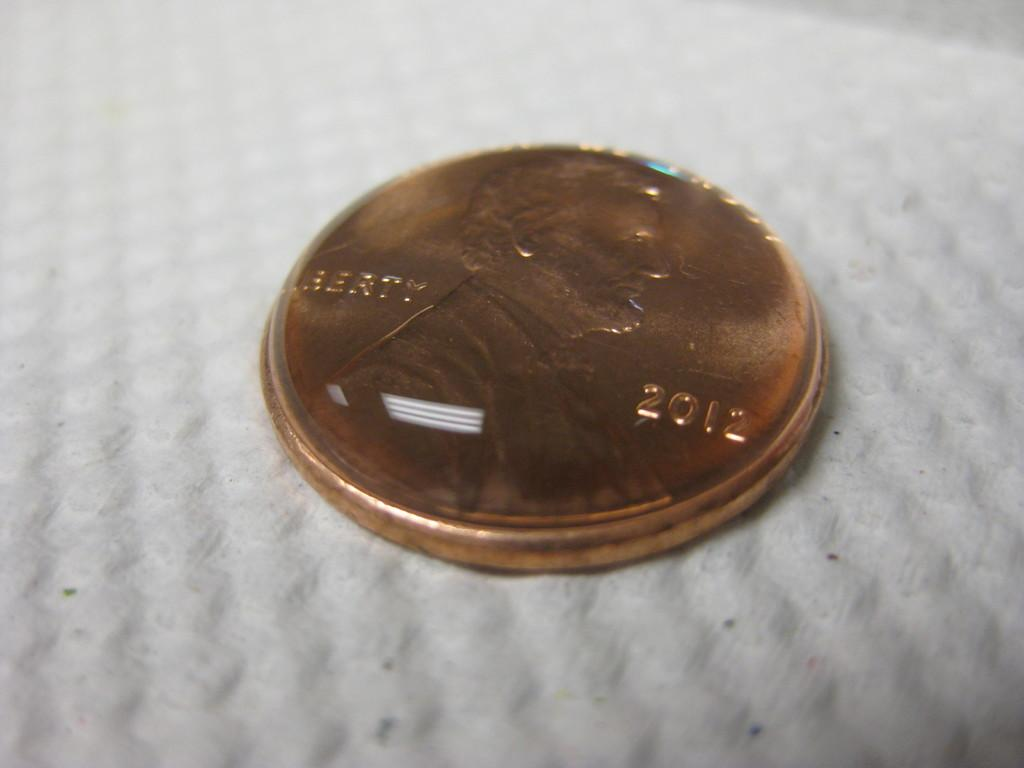Provide a one-sentence caption for the provided image. A 2012 copper penny is laying on head. 